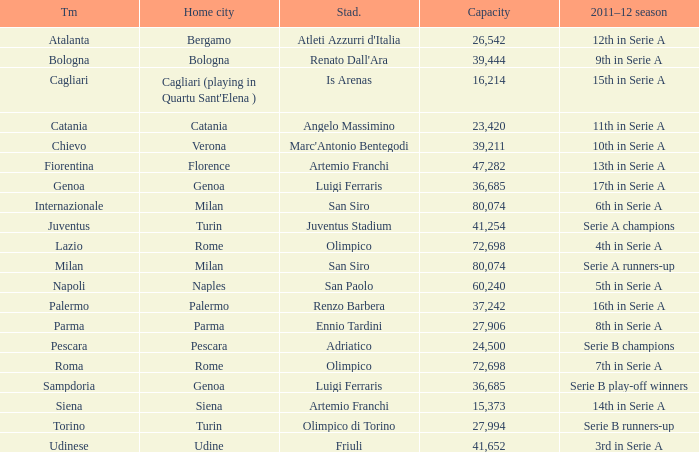What is the home city for angelo massimino stadium? Catania. 